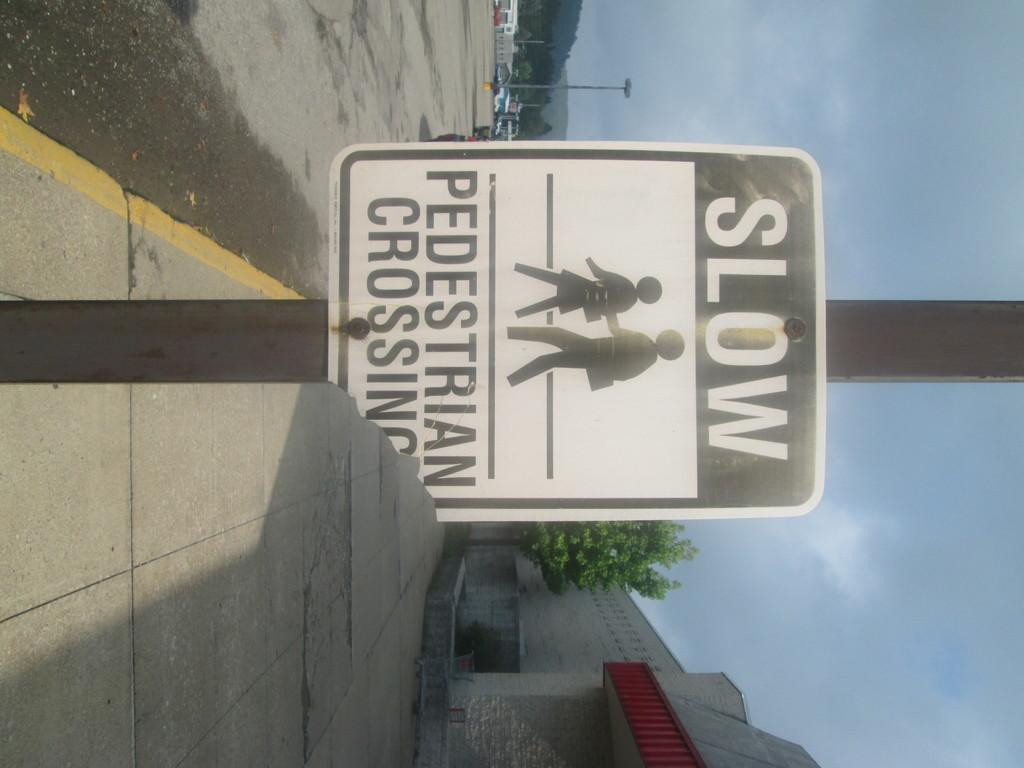What is the main object in the image with a warning message? There is a caution board in the image. How is the caution board positioned in the image? The caution board is attached to a pole. What information is displayed on the caution board? There is text on the caution board. What type of structures can be seen in the image? There are buildings visible in the image. What type of vegetation is present in the image? There are trees in the image. What type of lighting is present in the image? There is a pole light in the image. How would you describe the sky in the image? The sky is blue and cloudy in the image. How many pigs are flying in the sky in the image? There are no pigs present in the image, let alone flying ones. 